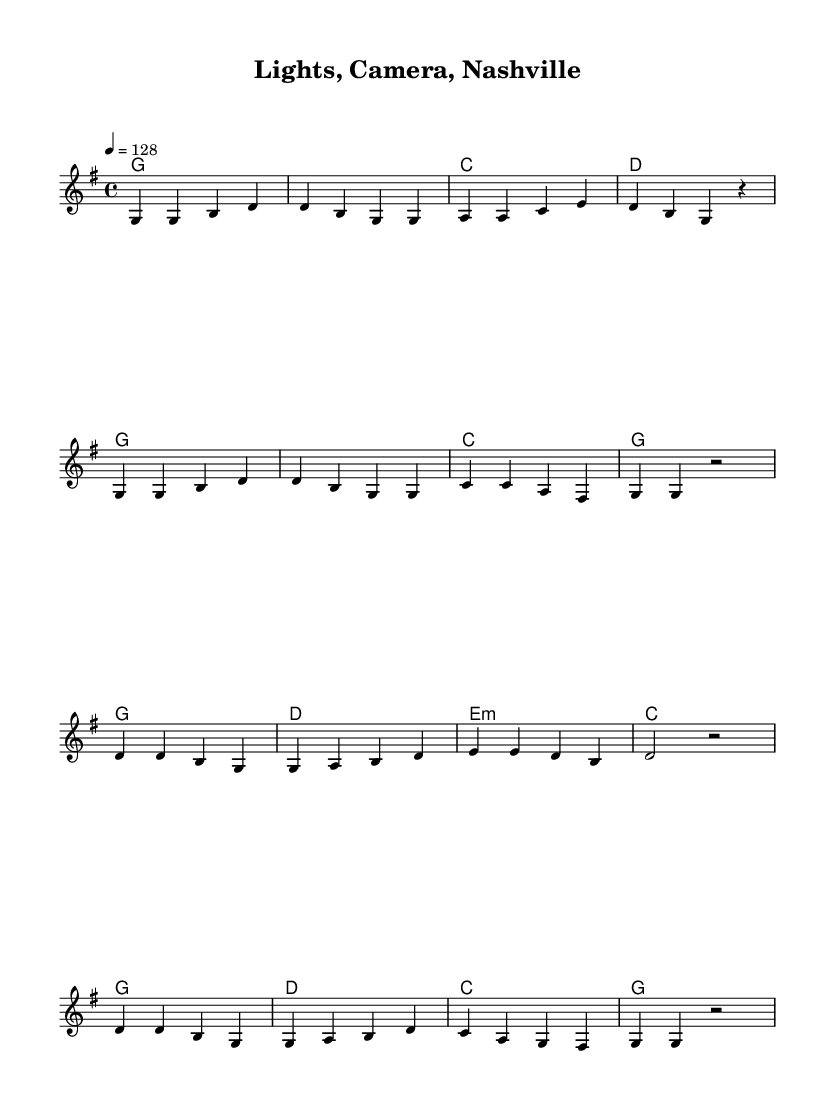What is the key signature of this music? The key signature is G major, which has one sharp (F#). This is determined by looking at the key signature at the beginning of the score.
Answer: G major What is the time signature of this music? The time signature is 4/4, indicated at the start of the piece. This means there are four beats in each measure and the quarter note gets one beat.
Answer: 4/4 What is the tempo marking for this music? The tempo marking is 128 beats per minute, indicated by the tempo notation "4 = 128". This specifies how many quarter note beats occur in one minute.
Answer: 128 How many measures are in the verse section? The verse section contains 8 measures as counted from the beginning of the melody to the end of the verse. Each measure is separated by vertical bar lines.
Answer: 8 What is the first chord in the chorus section? The first chord of the chorus section is G major, which can be identified as the first chord listed in the chord harmony section for the chorus.
Answer: G Which note appears most frequently in the melody? The note G appears most frequently in the melody, as it occurs multiple times throughout both the verse and chorus segments. This can be observed by counting the occurrences of the note G in the melody line.
Answer: G What type of song structure does this sheet music represent? This sheet music represents a verse-chorus structure, as it includes both distinct verse and chorus sections that alternate throughout the piece. This is a common structure found in country music.
Answer: Verse-chorus 